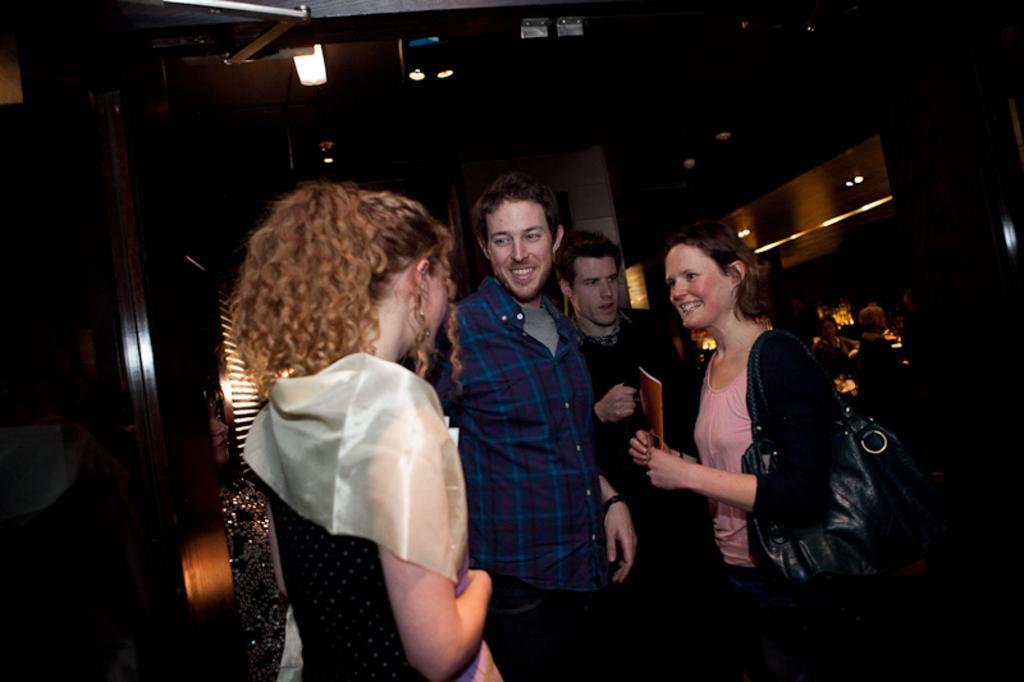Describe this image in one or two sentences. In this image there are a few people standing and talking with each other and one woman is holding a book in her hand, behind them there are people sitting in chairs, at the top of the image there are lights, behind them there is a wall. 